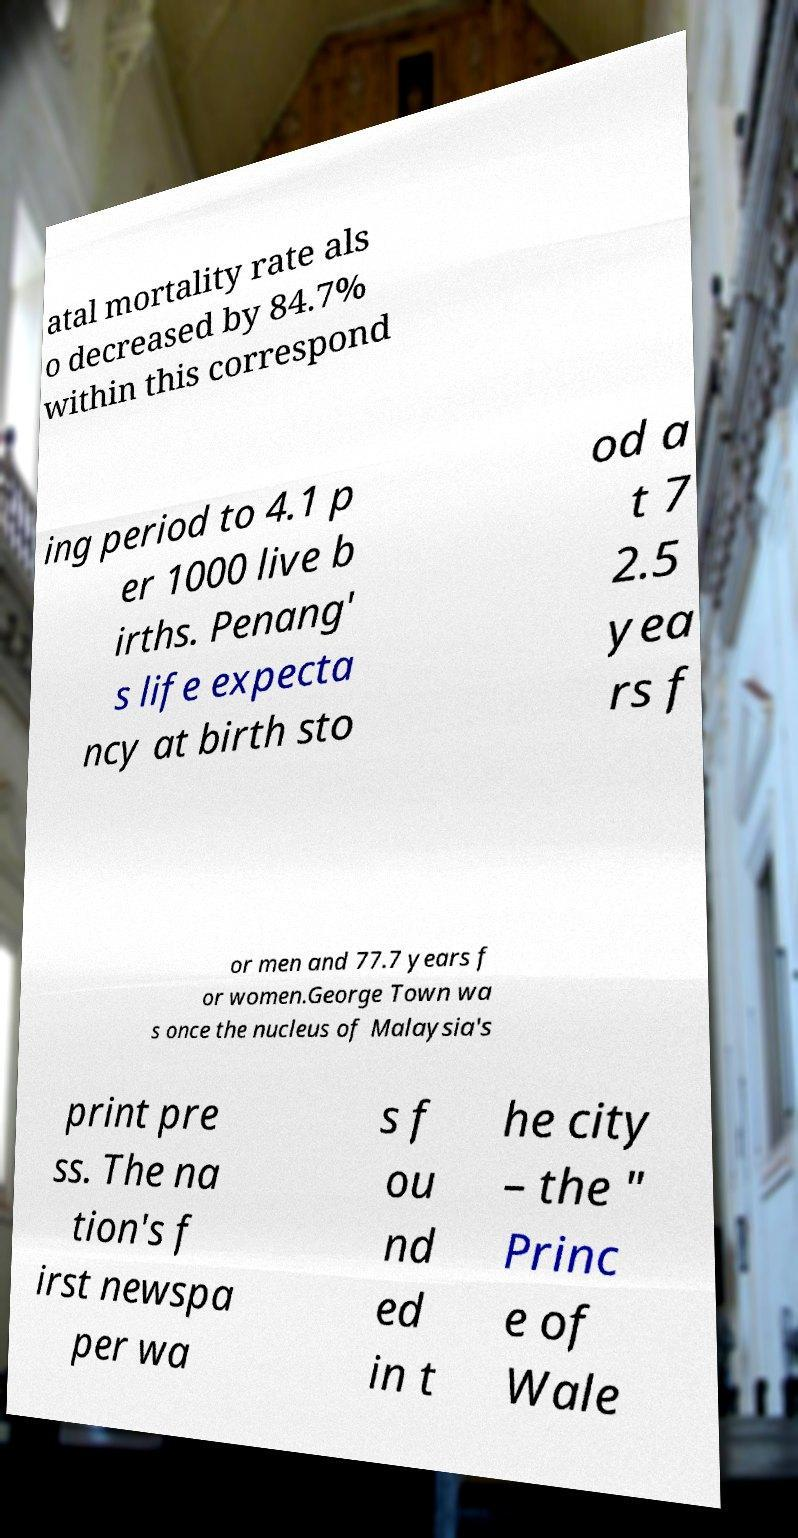Please identify and transcribe the text found in this image. atal mortality rate als o decreased by 84.7% within this correspond ing period to 4.1 p er 1000 live b irths. Penang' s life expecta ncy at birth sto od a t 7 2.5 yea rs f or men and 77.7 years f or women.George Town wa s once the nucleus of Malaysia's print pre ss. The na tion's f irst newspa per wa s f ou nd ed in t he city – the " Princ e of Wale 